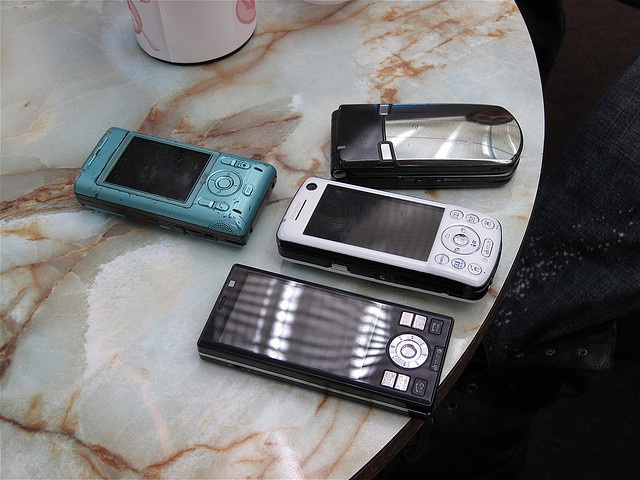Describe the objects in this image and their specific colors. I can see dining table in darkgray, black, gray, and lightgray tones, cell phone in darkgray, gray, black, and lavender tones, cell phone in darkgray, black, lightgray, and gray tones, cell phone in darkgray, black, teal, and gray tones, and cell phone in darkgray, black, lightgray, and gray tones in this image. 